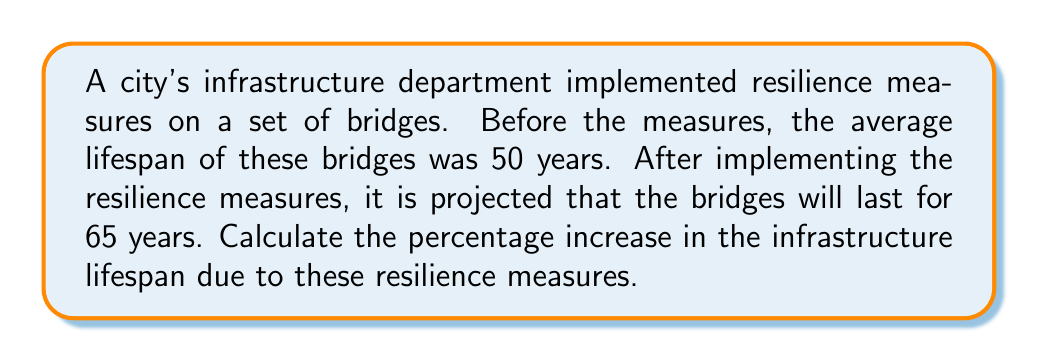Teach me how to tackle this problem. To calculate the percentage increase in infrastructure lifespan, we need to follow these steps:

1. Identify the initial lifespan: 50 years
2. Identify the new lifespan: 65 years
3. Calculate the increase in lifespan:
   $65 \text{ years} - 50 \text{ years} = 15 \text{ years}$
4. Calculate the percentage increase using the formula:
   $$\text{Percentage Increase} = \frac{\text{Increase}}{\text{Original Value}} \times 100\%$$

Plugging in our values:

$$\begin{align*}
\text{Percentage Increase} &= \frac{15 \text{ years}}{50 \text{ years}} \times 100\% \\[6pt]
&= 0.3 \times 100\% \\[6pt]
&= 30\%
\end{align*}$$

Therefore, the resilience measures increased the infrastructure lifespan by 30%.
Answer: The percentage increase in infrastructure lifespan due to resilience measures is 30%. 